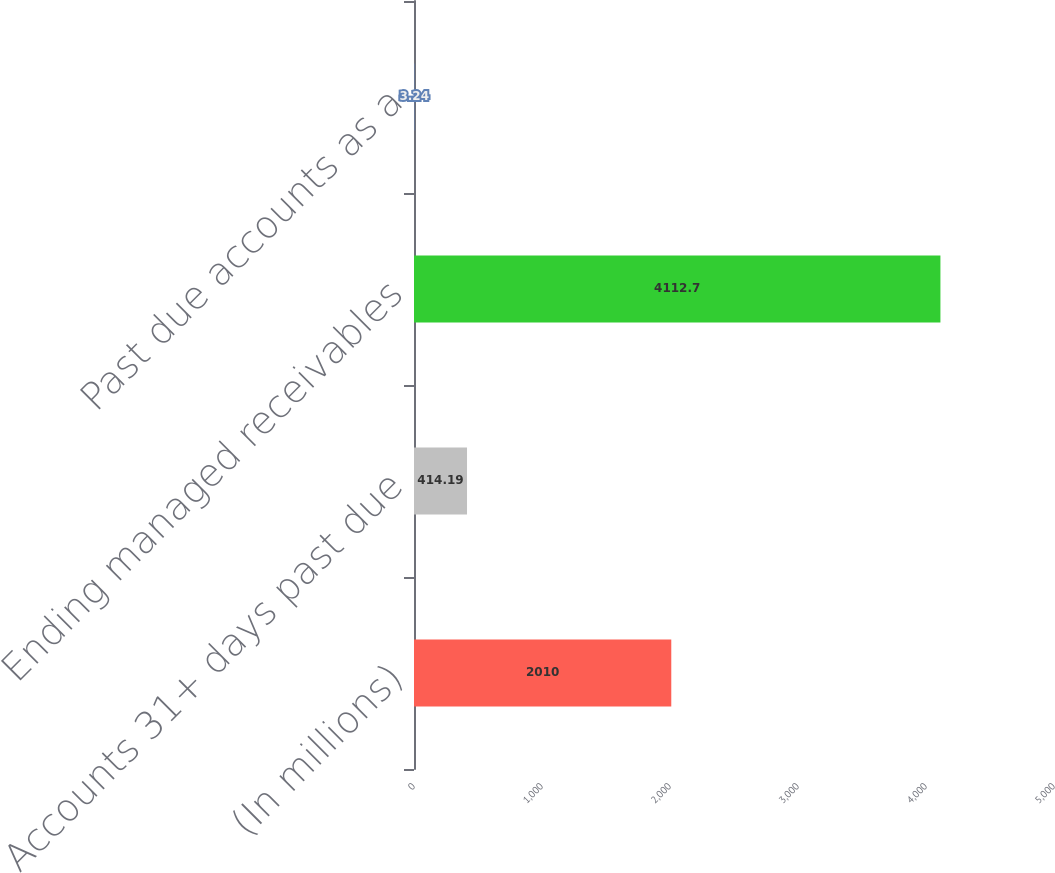Convert chart to OTSL. <chart><loc_0><loc_0><loc_500><loc_500><bar_chart><fcel>(In millions)<fcel>Accounts 31+ days past due<fcel>Ending managed receivables<fcel>Past due accounts as a<nl><fcel>2010<fcel>414.19<fcel>4112.7<fcel>3.24<nl></chart> 